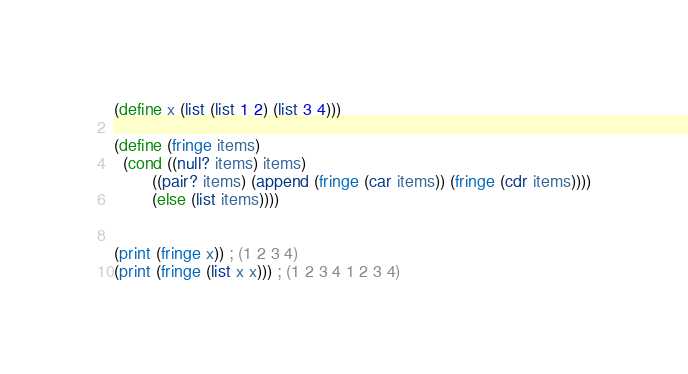<code> <loc_0><loc_0><loc_500><loc_500><_Scheme_>(define x (list (list 1 2) (list 3 4)))

(define (fringe items)
  (cond ((null? items) items)
        ((pair? items) (append (fringe (car items)) (fringe (cdr items))))
        (else (list items)))) 


(print (fringe x)) ; (1 2 3 4)
(print (fringe (list x x))) ; (1 2 3 4 1 2 3 4)
</code> 